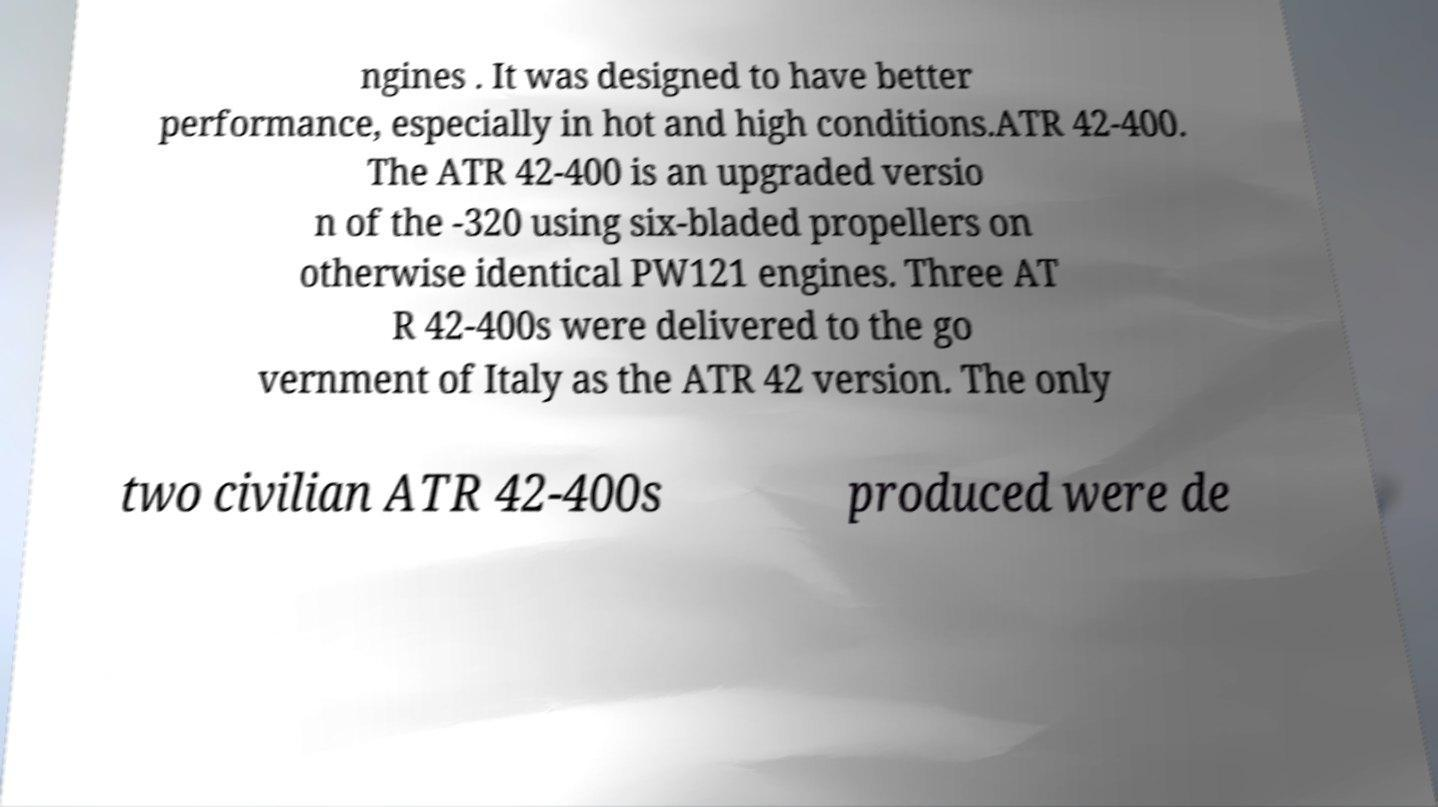Please read and relay the text visible in this image. What does it say? ngines . It was designed to have better performance, especially in hot and high conditions.ATR 42-400. The ATR 42-400 is an upgraded versio n of the -320 using six-bladed propellers on otherwise identical PW121 engines. Three AT R 42-400s were delivered to the go vernment of Italy as the ATR 42 version. The only two civilian ATR 42-400s produced were de 